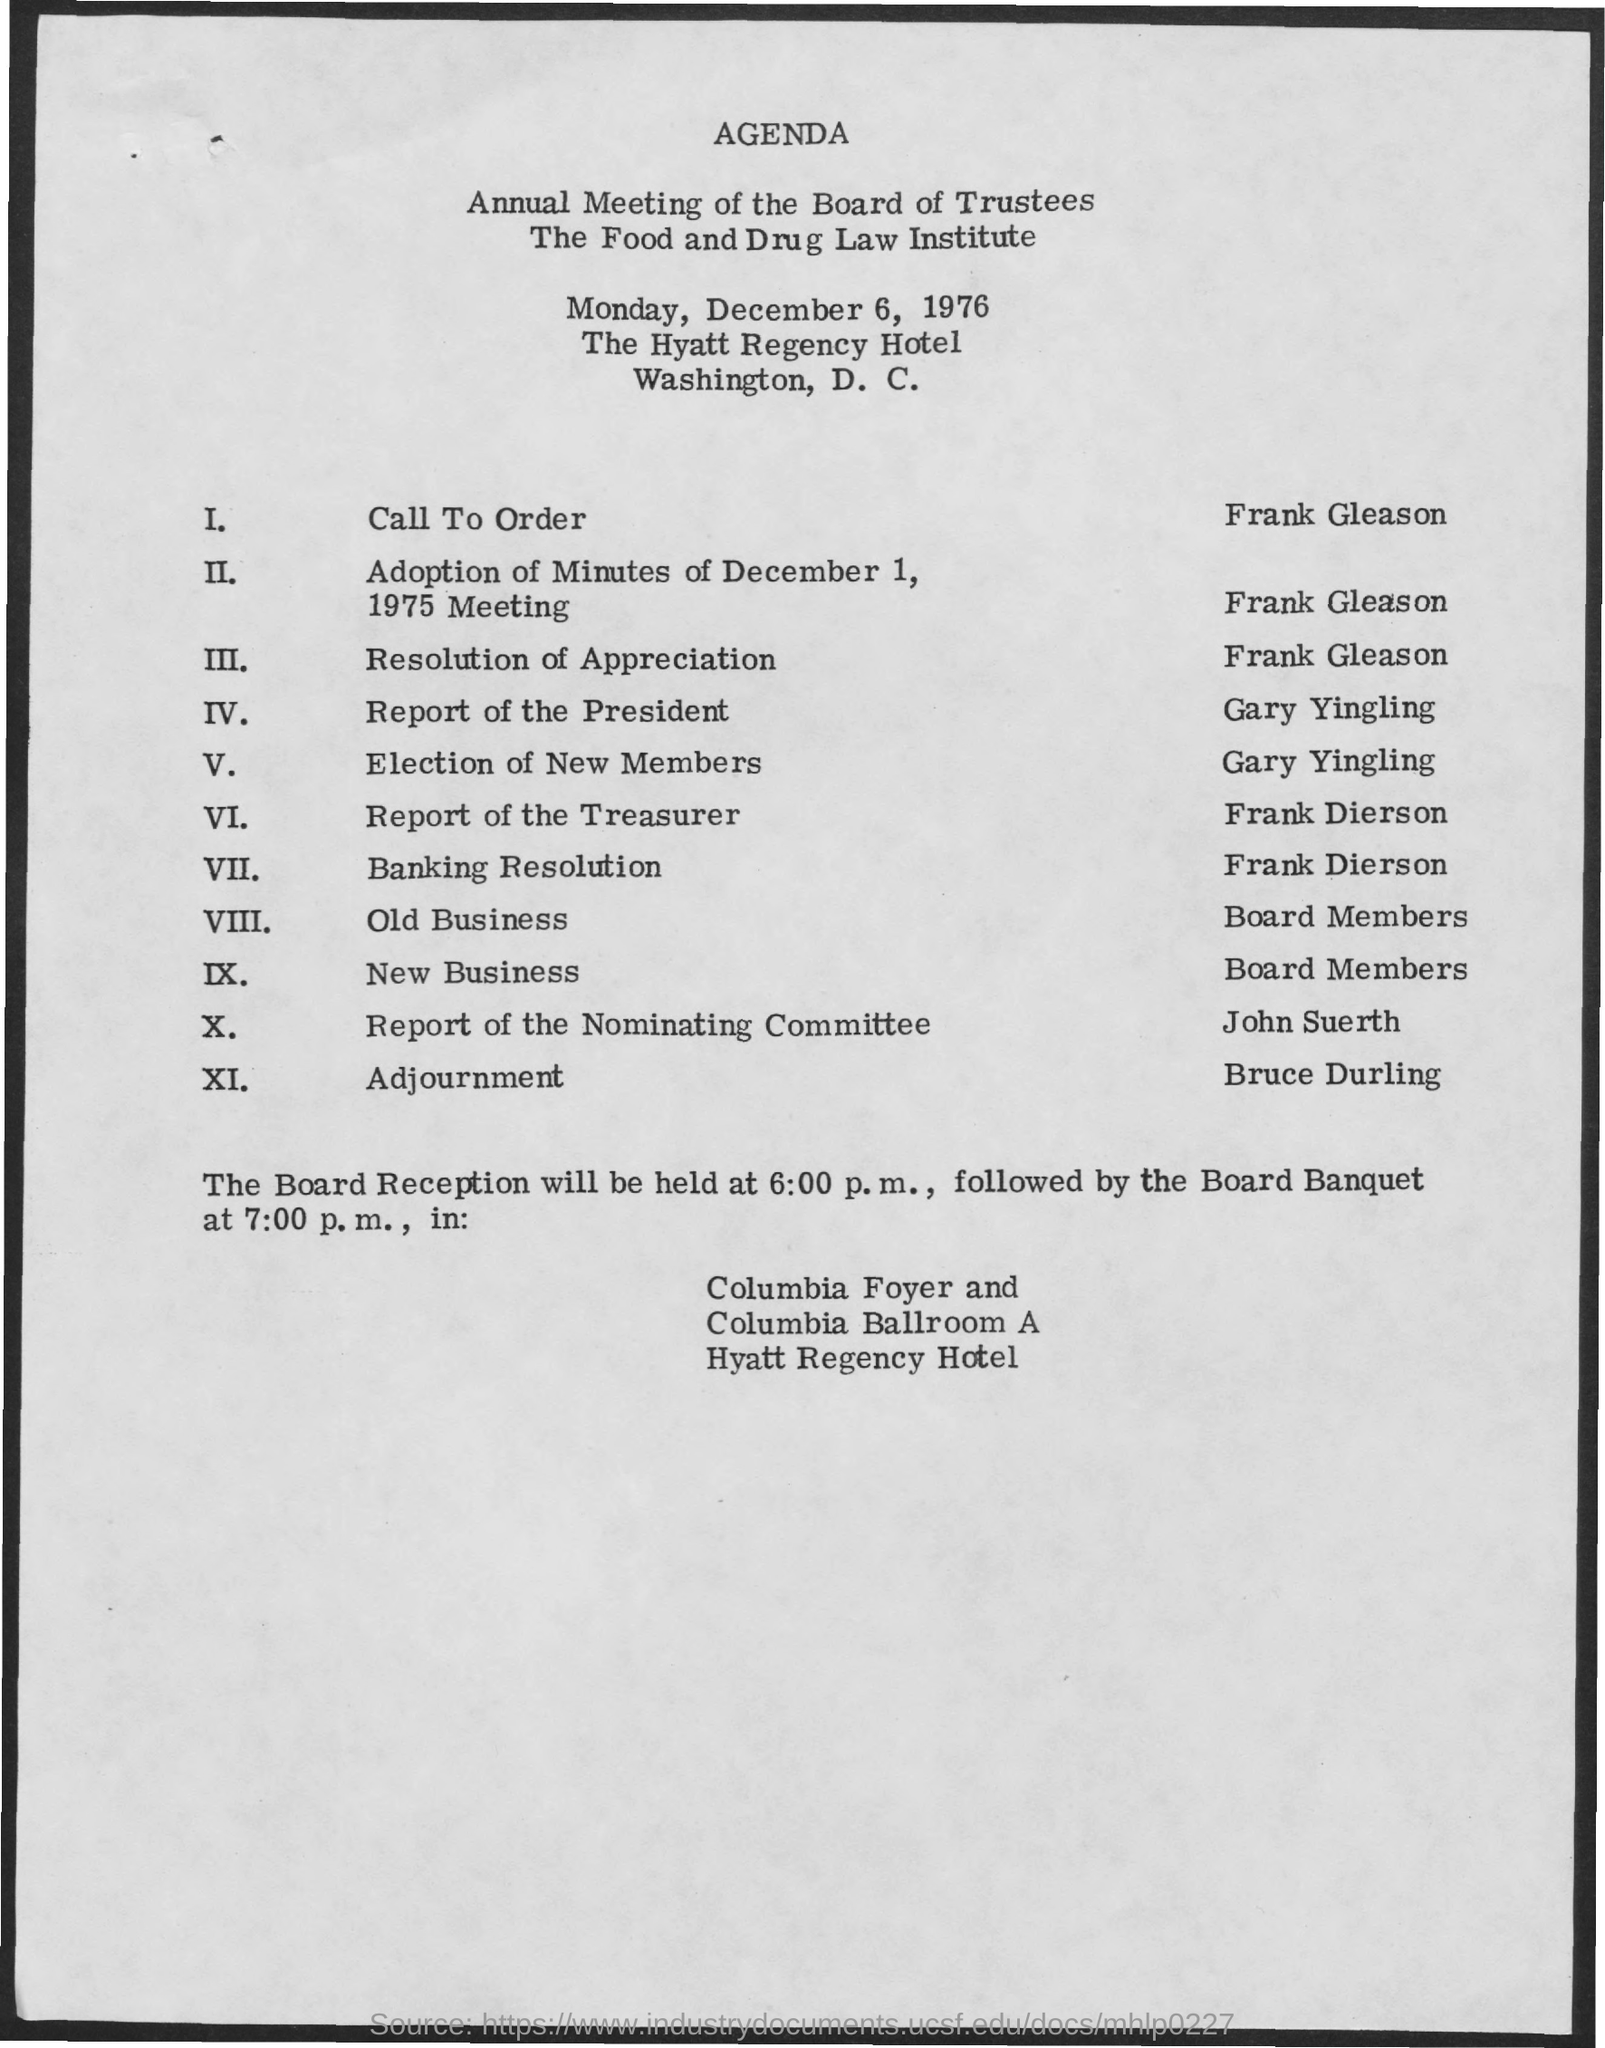Mention a couple of crucial points in this snapshot. The board reception is scheduled for 6:00 pm. The board banquet is scheduled to begin at 7:00 pm. The meeting was scheduled at the Hyatt Regency Hotel. The date for the annual meeting is scheduled to be held on December 6, 1976. 